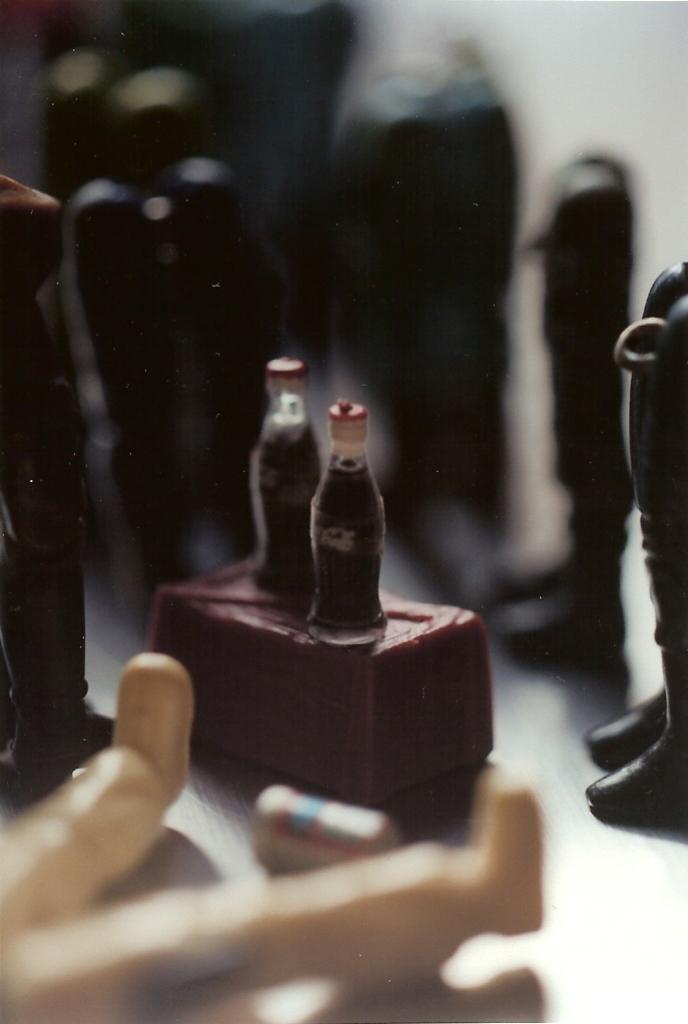What objects are in the image? There are small bottles in the image. Where are the bottles placed? The bottles are placed on a box. What other symbols or images can be seen in the image? There are shoe symbols in the image. How would you describe the quality of the image? The image is blurry. What type of bomb is depicted in the image? There is no bomb present in the image; it only contains small bottles, a box, and shoe symbols. 